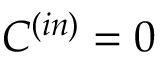<formula> <loc_0><loc_0><loc_500><loc_500>C ^ { ( i n ) } = 0</formula> 